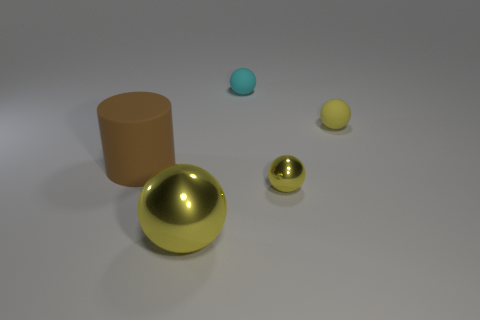How many objects are either matte balls that are in front of the cyan ball or matte balls?
Give a very brief answer. 2. There is a yellow object that is both right of the big metal ball and in front of the large brown matte thing; what is its size?
Ensure brevity in your answer.  Small. What is the size of the shiny sphere that is the same color as the big metallic object?
Offer a terse response. Small. How many other things are the same size as the yellow matte thing?
Give a very brief answer. 2. The metallic sphere that is behind the thing that is in front of the small thing that is in front of the big rubber cylinder is what color?
Ensure brevity in your answer.  Yellow. The matte object that is in front of the small cyan matte object and to the right of the large matte object has what shape?
Keep it short and to the point. Sphere. How many other things are there of the same shape as the big yellow thing?
Offer a terse response. 3. What is the shape of the matte thing behind the matte object that is on the right side of the yellow metallic sphere that is behind the large yellow sphere?
Make the answer very short. Sphere. How many objects are large brown things or tiny yellow balls right of the tiny yellow shiny object?
Your response must be concise. 2. There is a tiny yellow object behind the brown cylinder; is its shape the same as the yellow metallic object on the left side of the small yellow metal sphere?
Your response must be concise. Yes. 